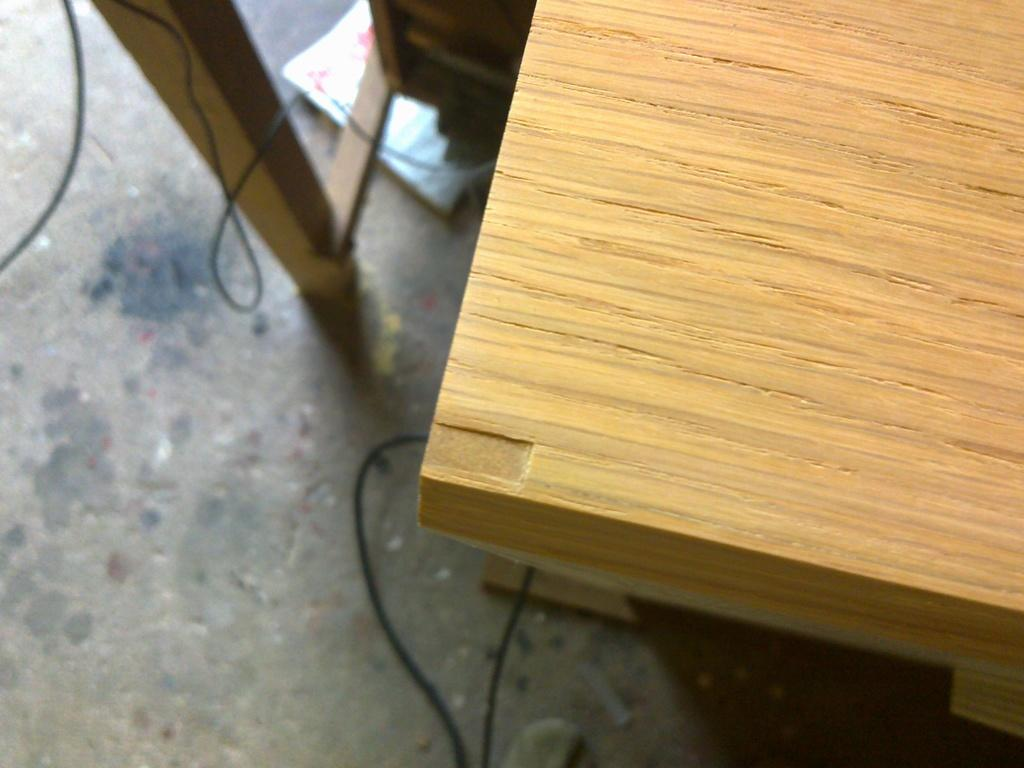What type of table is in the image? There is a wooden table in the image. Where is the table located? The table is on the ground. What can be seen on the ground in the image? Cable wires and papers are present on the ground. What type of jeans is the head wearing in the image? There is no head or jeans present in the image. 